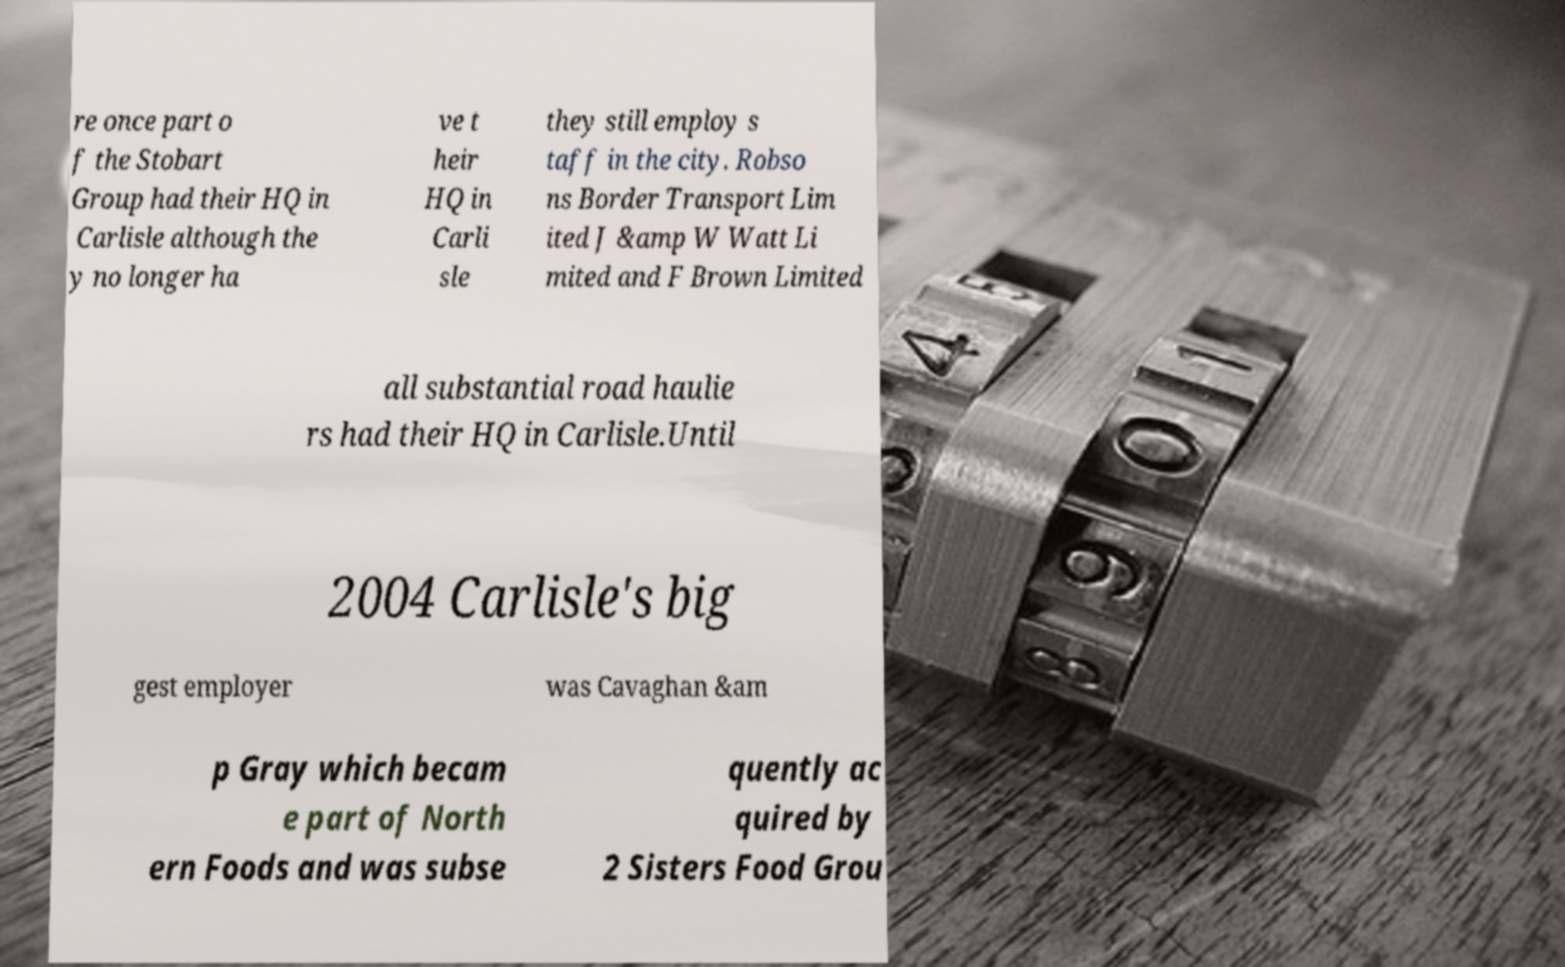I need the written content from this picture converted into text. Can you do that? re once part o f the Stobart Group had their HQ in Carlisle although the y no longer ha ve t heir HQ in Carli sle they still employ s taff in the city. Robso ns Border Transport Lim ited J &amp W Watt Li mited and F Brown Limited all substantial road haulie rs had their HQ in Carlisle.Until 2004 Carlisle's big gest employer was Cavaghan &am p Gray which becam e part of North ern Foods and was subse quently ac quired by 2 Sisters Food Grou 